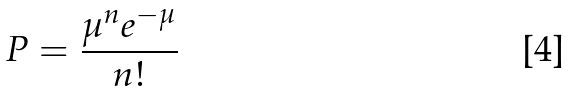<formula> <loc_0><loc_0><loc_500><loc_500>P = \frac { \mu ^ { n } e ^ { - \mu } } { n ! }</formula> 